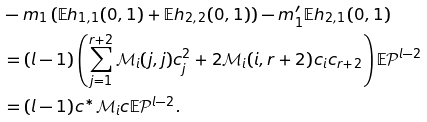<formula> <loc_0><loc_0><loc_500><loc_500>& - m _ { 1 } \left ( \mathbb { E } h _ { 1 , 1 } ( 0 , 1 ) + \mathbb { E } h _ { 2 , 2 } ( 0 , 1 ) \right ) - m _ { 1 } ^ { \prime } \mathbb { E } h _ { 2 , 1 } ( 0 , 1 ) \\ & = ( l - 1 ) \left ( \sum _ { j = 1 } ^ { r + 2 } \mathcal { M } _ { i } ( j , j ) c _ { j } ^ { 2 } + 2 \mathcal { M } _ { i } ( i , r + 2 ) c _ { i } c _ { r + 2 } \right ) \mathbb { E } \mathcal { P } ^ { l - 2 } \\ & = ( l - 1 ) c ^ { * } \mathcal { M } _ { i } c \mathbb { E } \mathcal { P } ^ { l - 2 } .</formula> 